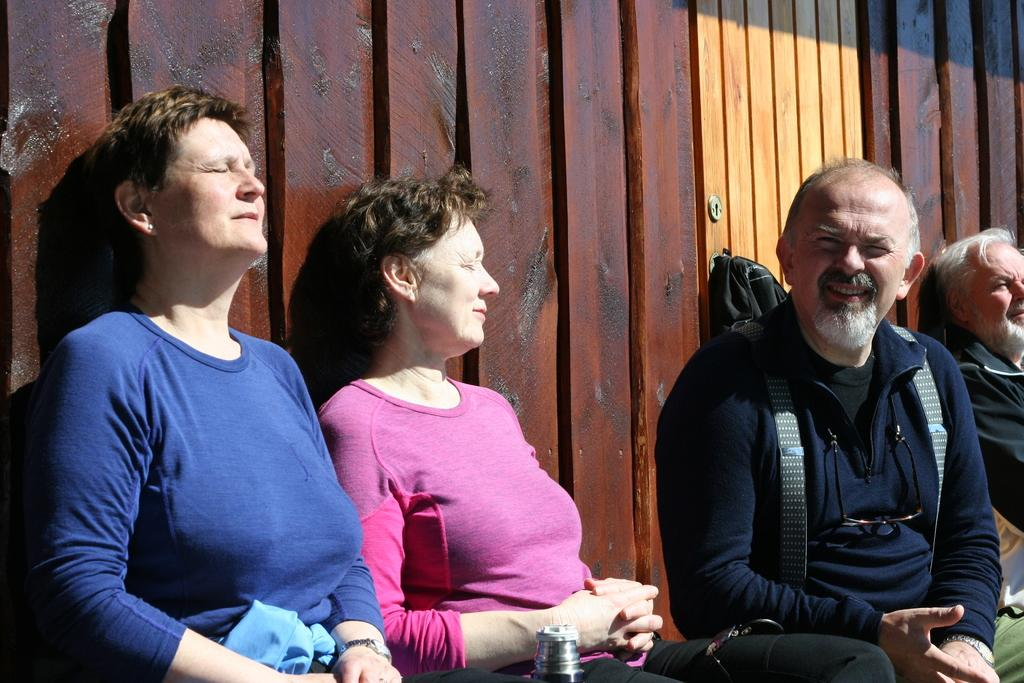How many individuals are present in the image? There are four people in the image. Can you describe the object in the image? Unfortunately, the facts provided do not give any details about the object in the image. What can be seen in the background of the image? There are wooden planks visible in the background of the image. What type of stem can be seen growing from the rail in the image? There is no stem or rail present in the image. How many scales are visible on the object in the image? As mentioned earlier, the facts provided do not give any details about the object in the image, so we cannot determine the number of scales. 